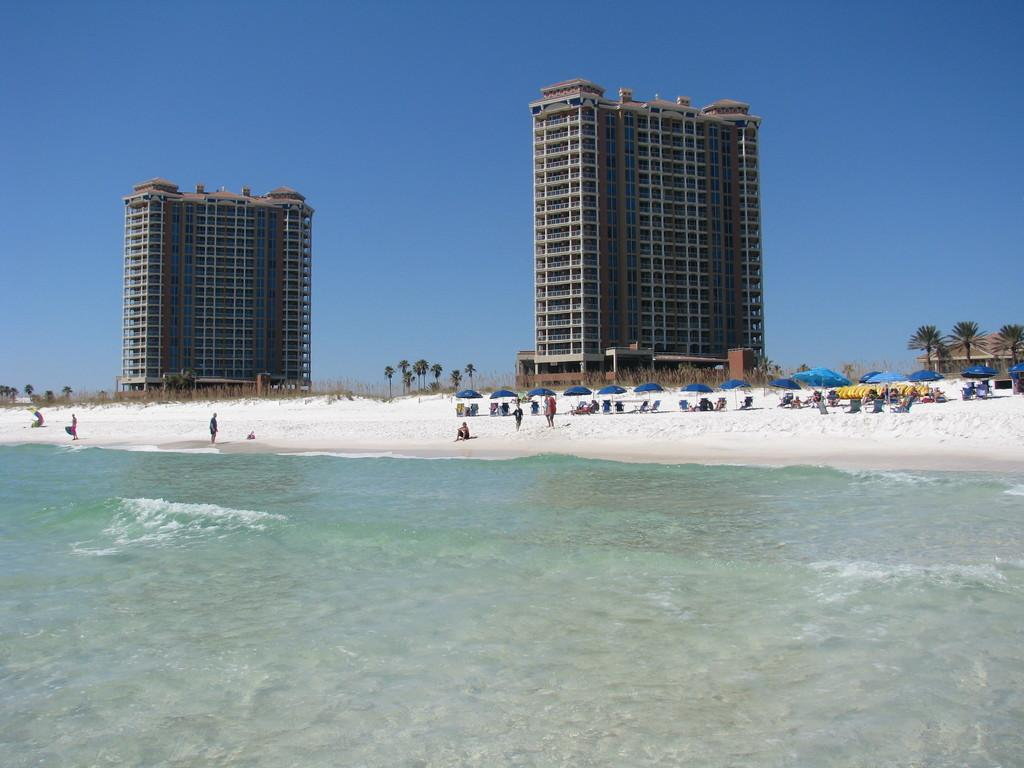What type of structures can be seen in the image? There are buildings in the image. Are there any people present in the image? Yes, there are people in the image. What objects are being used by the people in the image? Parasols are visible in the image. What is the terrain like in the image? There is water visible at the bottom of the image. What can be seen in the background of the image? There are trees and the sky visible in the background of the image. Where is the shed located in the image? The shed is on the right side of the image. How many toes are visible on the sock in the image? There is no sock present in the image. What type of company is conducting business in the image? There is no company conducting business in the image. 